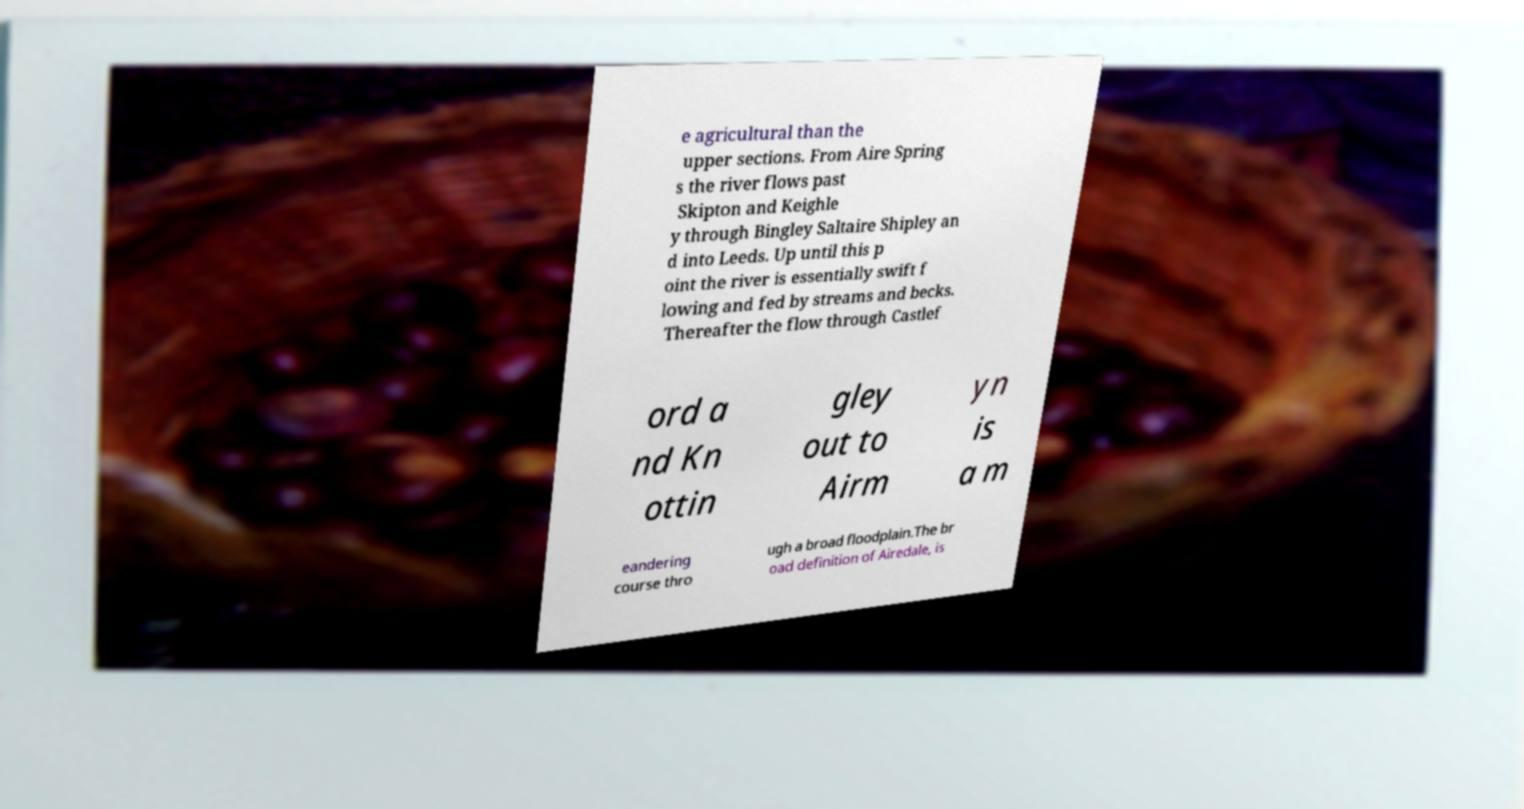For documentation purposes, I need the text within this image transcribed. Could you provide that? e agricultural than the upper sections. From Aire Spring s the river flows past Skipton and Keighle y through Bingley Saltaire Shipley an d into Leeds. Up until this p oint the river is essentially swift f lowing and fed by streams and becks. Thereafter the flow through Castlef ord a nd Kn ottin gley out to Airm yn is a m eandering course thro ugh a broad floodplain.The br oad definition of Airedale, is 